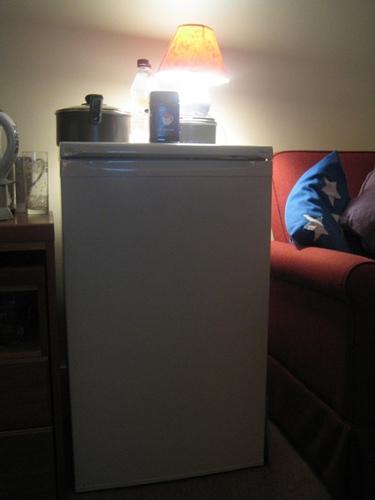What is the white shaped design which is on the blue pillow?
Keep it brief. Star. Where is the handle on the large appliance?
Quick response, please. Top. Is food cooked on this?
Concise answer only. No. 